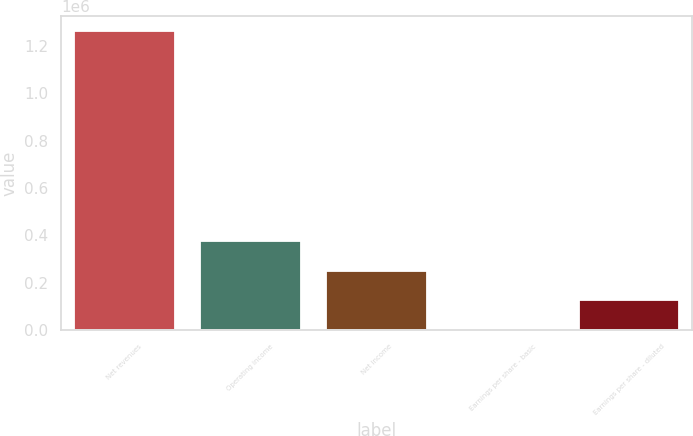Convert chart to OTSL. <chart><loc_0><loc_0><loc_500><loc_500><bar_chart><fcel>Net revenues<fcel>Operating income<fcel>Net income<fcel>Earnings per share - basic<fcel>Earnings per share - diluted<nl><fcel>1.26041e+06<fcel>378122<fcel>252082<fcel>0.13<fcel>126041<nl></chart> 